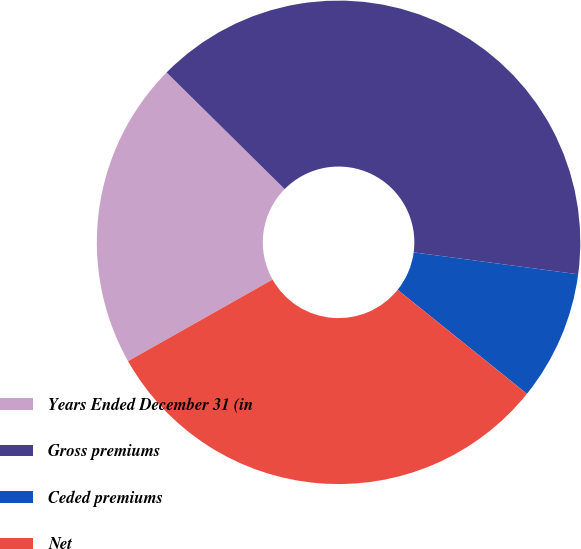<chart> <loc_0><loc_0><loc_500><loc_500><pie_chart><fcel>Years Ended December 31 (in<fcel>Gross premiums<fcel>Ceded premiums<fcel>Net<nl><fcel>20.58%<fcel>39.71%<fcel>8.67%<fcel>31.04%<nl></chart> 